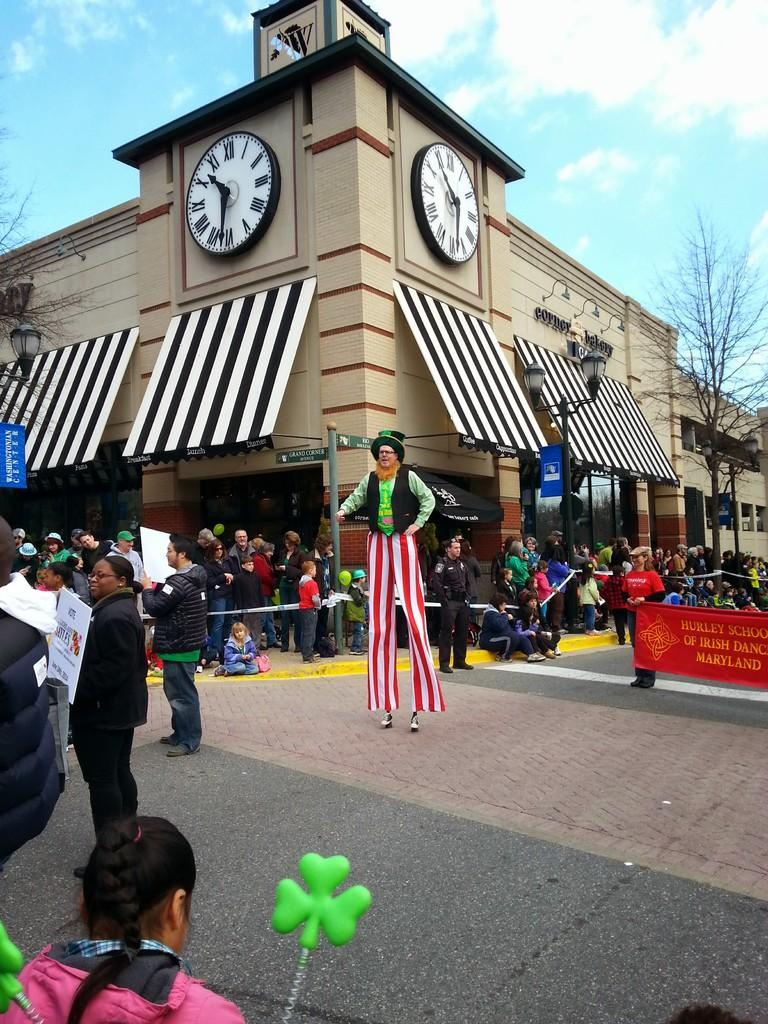<image>
Write a terse but informative summary of the picture. A parade with someone on stilts and the Hurley School of Irish Dance. 